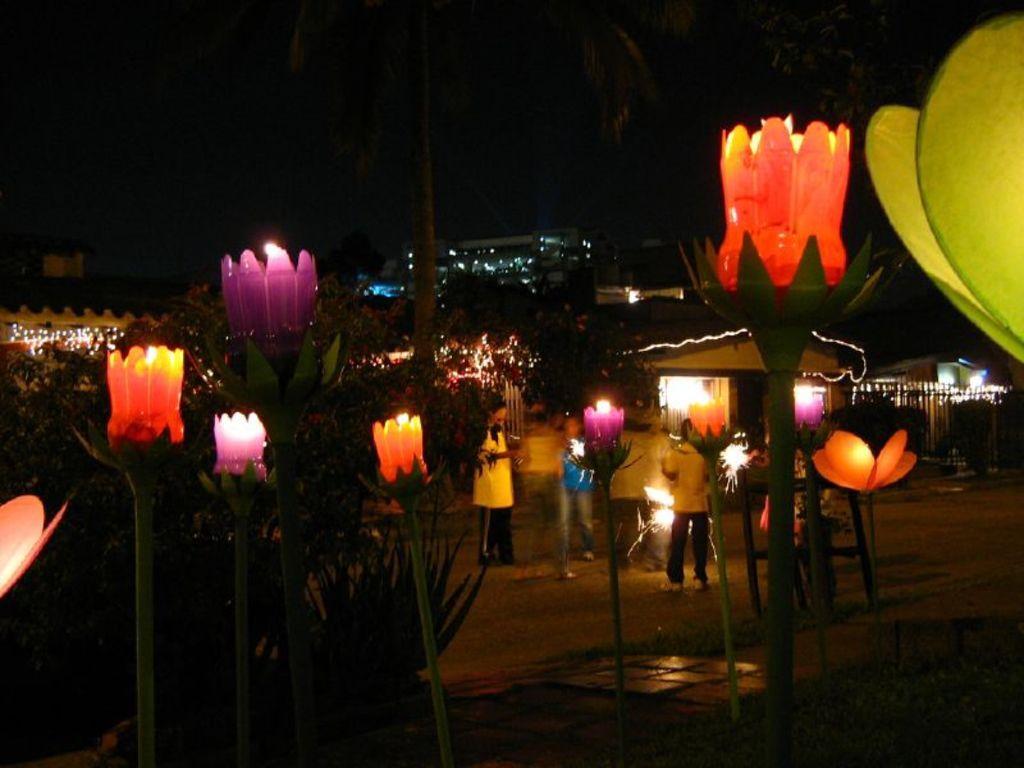Could you give a brief overview of what you see in this image? In this picture I can see people standing on the ground. In the background I can see house, buildings and trees. In the front of the image I can see candles. 